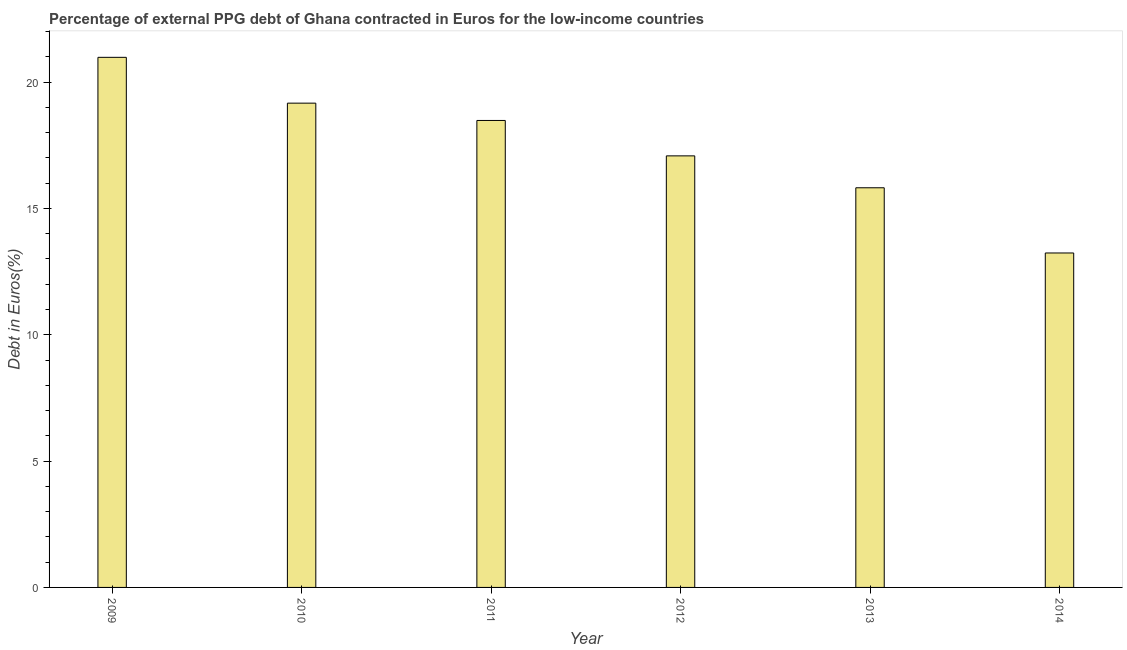Does the graph contain any zero values?
Your answer should be very brief. No. Does the graph contain grids?
Make the answer very short. No. What is the title of the graph?
Give a very brief answer. Percentage of external PPG debt of Ghana contracted in Euros for the low-income countries. What is the label or title of the X-axis?
Provide a succinct answer. Year. What is the label or title of the Y-axis?
Offer a very short reply. Debt in Euros(%). What is the currency composition of ppg debt in 2012?
Provide a succinct answer. 17.08. Across all years, what is the maximum currency composition of ppg debt?
Your answer should be very brief. 20.98. Across all years, what is the minimum currency composition of ppg debt?
Provide a succinct answer. 13.24. What is the sum of the currency composition of ppg debt?
Make the answer very short. 104.76. What is the difference between the currency composition of ppg debt in 2012 and 2013?
Provide a short and direct response. 1.26. What is the average currency composition of ppg debt per year?
Your answer should be very brief. 17.46. What is the median currency composition of ppg debt?
Give a very brief answer. 17.78. Do a majority of the years between 2011 and 2010 (inclusive) have currency composition of ppg debt greater than 20 %?
Offer a terse response. No. What is the ratio of the currency composition of ppg debt in 2009 to that in 2010?
Ensure brevity in your answer.  1.09. Is the currency composition of ppg debt in 2009 less than that in 2012?
Keep it short and to the point. No. What is the difference between the highest and the second highest currency composition of ppg debt?
Offer a very short reply. 1.81. Is the sum of the currency composition of ppg debt in 2010 and 2014 greater than the maximum currency composition of ppg debt across all years?
Ensure brevity in your answer.  Yes. What is the difference between the highest and the lowest currency composition of ppg debt?
Ensure brevity in your answer.  7.74. How many bars are there?
Give a very brief answer. 6. Are all the bars in the graph horizontal?
Ensure brevity in your answer.  No. How many years are there in the graph?
Your answer should be very brief. 6. What is the difference between two consecutive major ticks on the Y-axis?
Give a very brief answer. 5. Are the values on the major ticks of Y-axis written in scientific E-notation?
Your answer should be compact. No. What is the Debt in Euros(%) in 2009?
Ensure brevity in your answer.  20.98. What is the Debt in Euros(%) of 2010?
Your answer should be compact. 19.17. What is the Debt in Euros(%) in 2011?
Keep it short and to the point. 18.48. What is the Debt in Euros(%) of 2012?
Offer a very short reply. 17.08. What is the Debt in Euros(%) in 2013?
Your answer should be compact. 15.82. What is the Debt in Euros(%) in 2014?
Offer a terse response. 13.24. What is the difference between the Debt in Euros(%) in 2009 and 2010?
Give a very brief answer. 1.81. What is the difference between the Debt in Euros(%) in 2009 and 2011?
Offer a very short reply. 2.5. What is the difference between the Debt in Euros(%) in 2009 and 2012?
Make the answer very short. 3.9. What is the difference between the Debt in Euros(%) in 2009 and 2013?
Keep it short and to the point. 5.16. What is the difference between the Debt in Euros(%) in 2009 and 2014?
Keep it short and to the point. 7.74. What is the difference between the Debt in Euros(%) in 2010 and 2011?
Provide a succinct answer. 0.69. What is the difference between the Debt in Euros(%) in 2010 and 2012?
Your answer should be compact. 2.09. What is the difference between the Debt in Euros(%) in 2010 and 2013?
Provide a succinct answer. 3.35. What is the difference between the Debt in Euros(%) in 2010 and 2014?
Offer a terse response. 5.93. What is the difference between the Debt in Euros(%) in 2011 and 2012?
Your answer should be very brief. 1.4. What is the difference between the Debt in Euros(%) in 2011 and 2013?
Your response must be concise. 2.66. What is the difference between the Debt in Euros(%) in 2011 and 2014?
Make the answer very short. 5.24. What is the difference between the Debt in Euros(%) in 2012 and 2013?
Your answer should be compact. 1.26. What is the difference between the Debt in Euros(%) in 2012 and 2014?
Keep it short and to the point. 3.84. What is the difference between the Debt in Euros(%) in 2013 and 2014?
Keep it short and to the point. 2.58. What is the ratio of the Debt in Euros(%) in 2009 to that in 2010?
Ensure brevity in your answer.  1.09. What is the ratio of the Debt in Euros(%) in 2009 to that in 2011?
Provide a succinct answer. 1.14. What is the ratio of the Debt in Euros(%) in 2009 to that in 2012?
Give a very brief answer. 1.23. What is the ratio of the Debt in Euros(%) in 2009 to that in 2013?
Ensure brevity in your answer.  1.33. What is the ratio of the Debt in Euros(%) in 2009 to that in 2014?
Give a very brief answer. 1.58. What is the ratio of the Debt in Euros(%) in 2010 to that in 2012?
Offer a very short reply. 1.12. What is the ratio of the Debt in Euros(%) in 2010 to that in 2013?
Keep it short and to the point. 1.21. What is the ratio of the Debt in Euros(%) in 2010 to that in 2014?
Offer a terse response. 1.45. What is the ratio of the Debt in Euros(%) in 2011 to that in 2012?
Provide a succinct answer. 1.08. What is the ratio of the Debt in Euros(%) in 2011 to that in 2013?
Keep it short and to the point. 1.17. What is the ratio of the Debt in Euros(%) in 2011 to that in 2014?
Your answer should be compact. 1.4. What is the ratio of the Debt in Euros(%) in 2012 to that in 2013?
Provide a short and direct response. 1.08. What is the ratio of the Debt in Euros(%) in 2012 to that in 2014?
Offer a terse response. 1.29. What is the ratio of the Debt in Euros(%) in 2013 to that in 2014?
Provide a succinct answer. 1.2. 